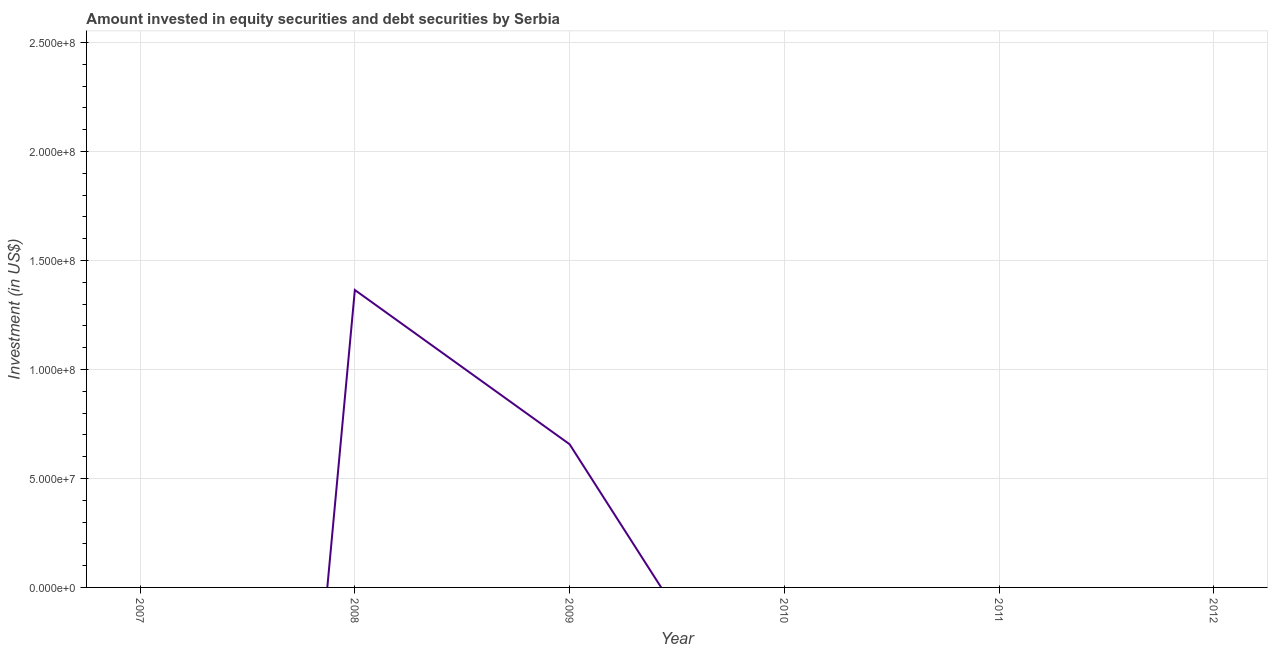What is the portfolio investment in 2008?
Ensure brevity in your answer.  1.36e+08. Across all years, what is the maximum portfolio investment?
Offer a very short reply. 1.36e+08. What is the sum of the portfolio investment?
Give a very brief answer. 2.02e+08. What is the difference between the portfolio investment in 2008 and 2009?
Provide a succinct answer. 7.08e+07. What is the average portfolio investment per year?
Keep it short and to the point. 3.37e+07. What is the median portfolio investment?
Make the answer very short. 0. Is the portfolio investment in 2008 less than that in 2009?
Provide a succinct answer. No. Is the difference between the portfolio investment in 2008 and 2009 greater than the difference between any two years?
Your answer should be very brief. No. What is the difference between the highest and the lowest portfolio investment?
Ensure brevity in your answer.  1.36e+08. Does the portfolio investment monotonically increase over the years?
Your answer should be very brief. No. How many years are there in the graph?
Provide a short and direct response. 6. What is the difference between two consecutive major ticks on the Y-axis?
Your response must be concise. 5.00e+07. Does the graph contain any zero values?
Keep it short and to the point. Yes. What is the title of the graph?
Give a very brief answer. Amount invested in equity securities and debt securities by Serbia. What is the label or title of the X-axis?
Your answer should be compact. Year. What is the label or title of the Y-axis?
Offer a terse response. Investment (in US$). What is the Investment (in US$) of 2007?
Your answer should be compact. 0. What is the Investment (in US$) in 2008?
Your response must be concise. 1.36e+08. What is the Investment (in US$) in 2009?
Make the answer very short. 6.57e+07. What is the Investment (in US$) of 2011?
Offer a terse response. 0. What is the difference between the Investment (in US$) in 2008 and 2009?
Your answer should be compact. 7.08e+07. What is the ratio of the Investment (in US$) in 2008 to that in 2009?
Provide a short and direct response. 2.08. 